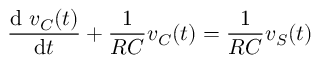<formula> <loc_0><loc_0><loc_500><loc_500>{ \frac { d \ v _ { C } ( t ) } { d t } } + { \frac { 1 } { R C } } v _ { C } ( t ) = { \frac { 1 } { R C } } v _ { S } ( t )</formula> 